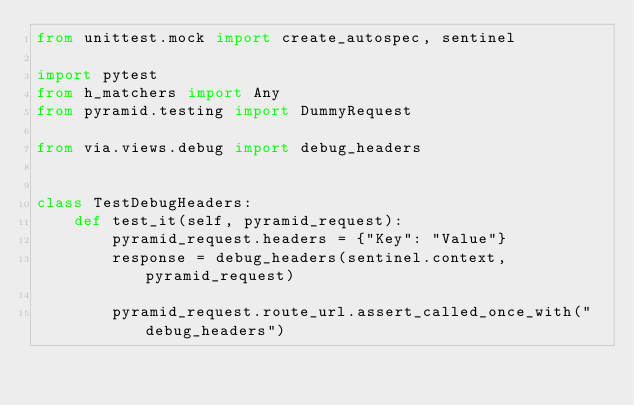Convert code to text. <code><loc_0><loc_0><loc_500><loc_500><_Python_>from unittest.mock import create_autospec, sentinel

import pytest
from h_matchers import Any
from pyramid.testing import DummyRequest

from via.views.debug import debug_headers


class TestDebugHeaders:
    def test_it(self, pyramid_request):
        pyramid_request.headers = {"Key": "Value"}
        response = debug_headers(sentinel.context, pyramid_request)

        pyramid_request.route_url.assert_called_once_with("debug_headers")
</code> 